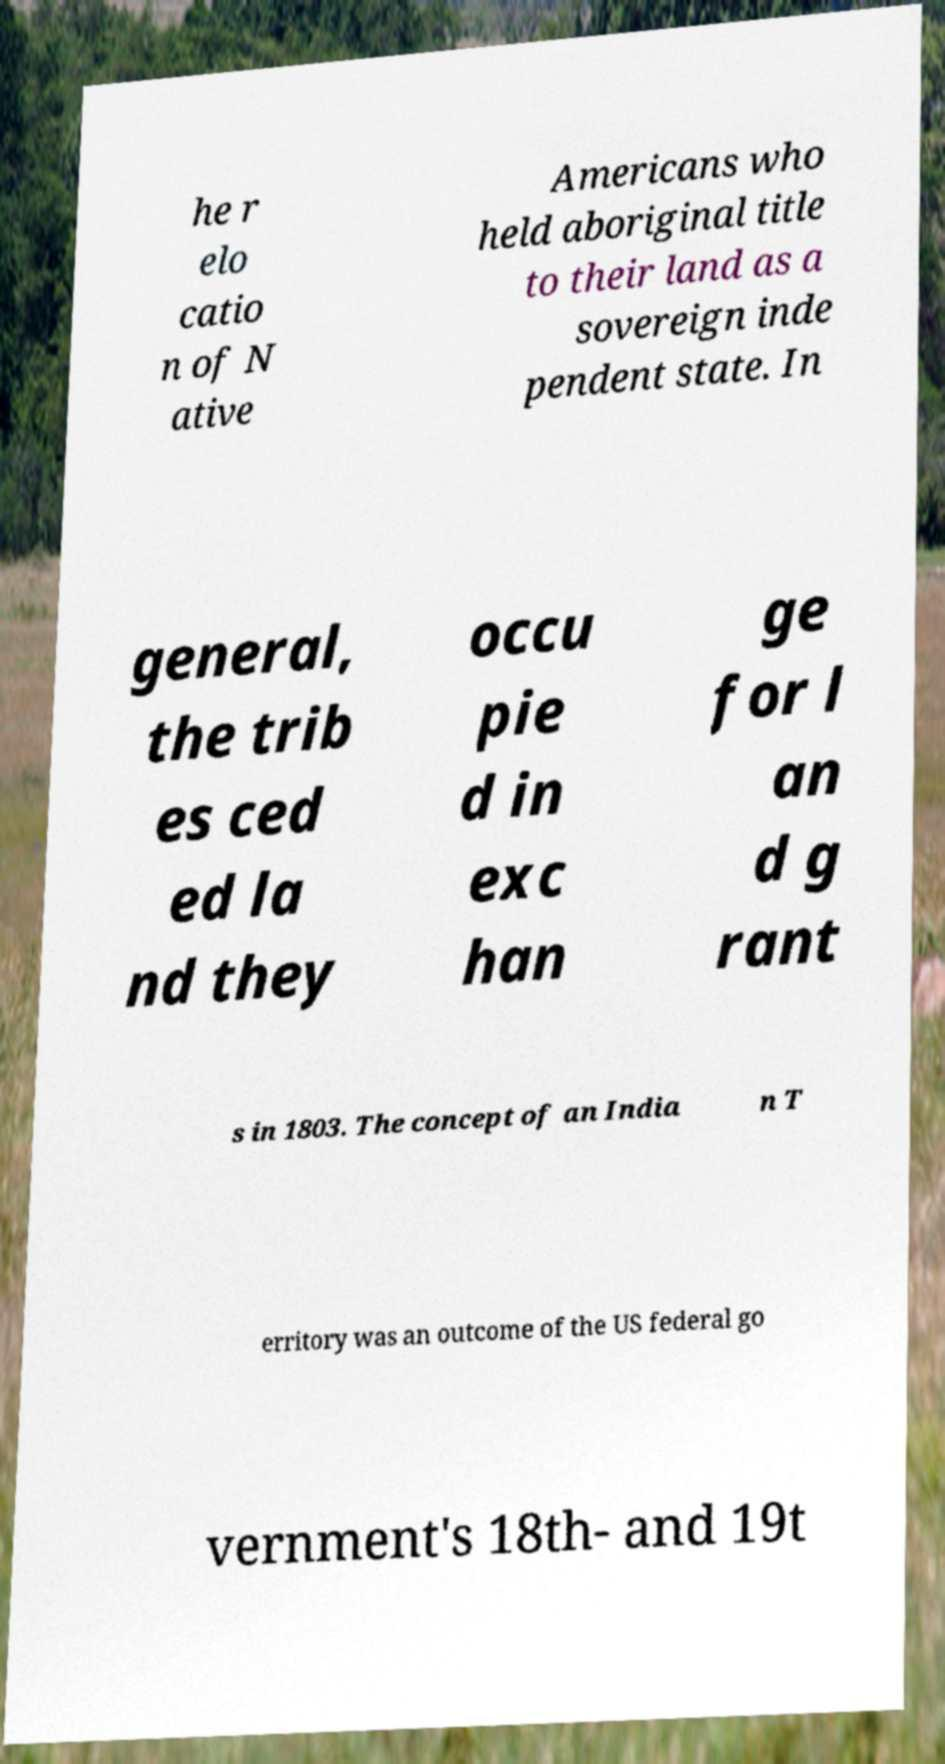Can you read and provide the text displayed in the image?This photo seems to have some interesting text. Can you extract and type it out for me? he r elo catio n of N ative Americans who held aboriginal title to their land as a sovereign inde pendent state. In general, the trib es ced ed la nd they occu pie d in exc han ge for l an d g rant s in 1803. The concept of an India n T erritory was an outcome of the US federal go vernment's 18th- and 19t 